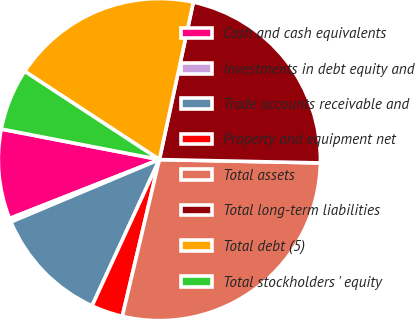<chart> <loc_0><loc_0><loc_500><loc_500><pie_chart><fcel>Cash and cash equivalents<fcel>Investments in debt equity and<fcel>Trade accounts receivable and<fcel>Property and equipment net<fcel>Total assets<fcel>Total long-term liabilities<fcel>Total debt (5)<fcel>Total stockholders ' equity<nl><fcel>9.0%<fcel>0.37%<fcel>11.8%<fcel>3.17%<fcel>28.37%<fcel>21.95%<fcel>19.15%<fcel>6.2%<nl></chart> 